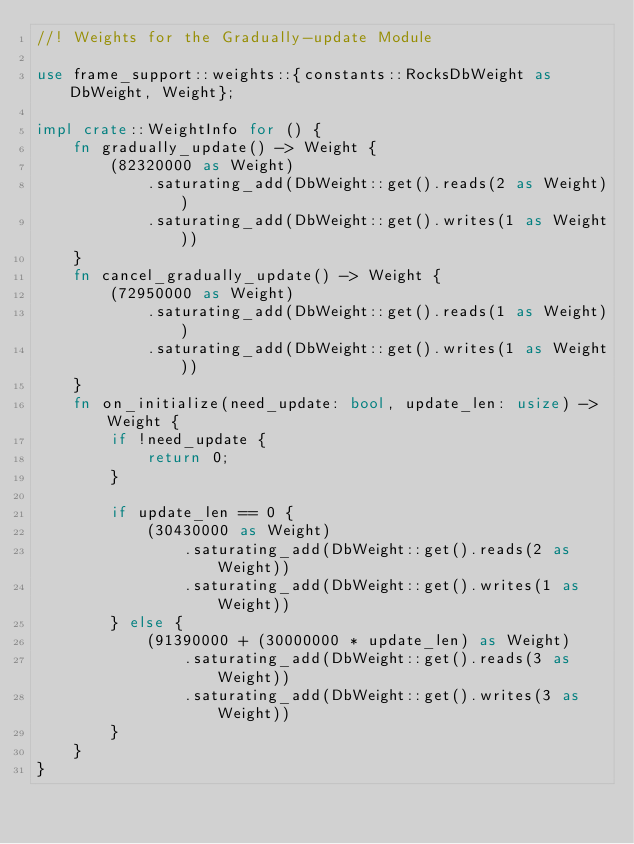Convert code to text. <code><loc_0><loc_0><loc_500><loc_500><_Rust_>//! Weights for the Gradually-update Module

use frame_support::weights::{constants::RocksDbWeight as DbWeight, Weight};

impl crate::WeightInfo for () {
	fn gradually_update() -> Weight {
		(82320000 as Weight)
			.saturating_add(DbWeight::get().reads(2 as Weight))
			.saturating_add(DbWeight::get().writes(1 as Weight))
	}
	fn cancel_gradually_update() -> Weight {
		(72950000 as Weight)
			.saturating_add(DbWeight::get().reads(1 as Weight))
			.saturating_add(DbWeight::get().writes(1 as Weight))
	}
	fn on_initialize(need_update: bool, update_len: usize) -> Weight {
		if !need_update {
			return 0;
		}

		if update_len == 0 {
			(30430000 as Weight)
				.saturating_add(DbWeight::get().reads(2 as Weight))
				.saturating_add(DbWeight::get().writes(1 as Weight))
		} else {
			(91390000 + (30000000 * update_len) as Weight)
				.saturating_add(DbWeight::get().reads(3 as Weight))
				.saturating_add(DbWeight::get().writes(3 as Weight))
		}
	}
}
</code> 